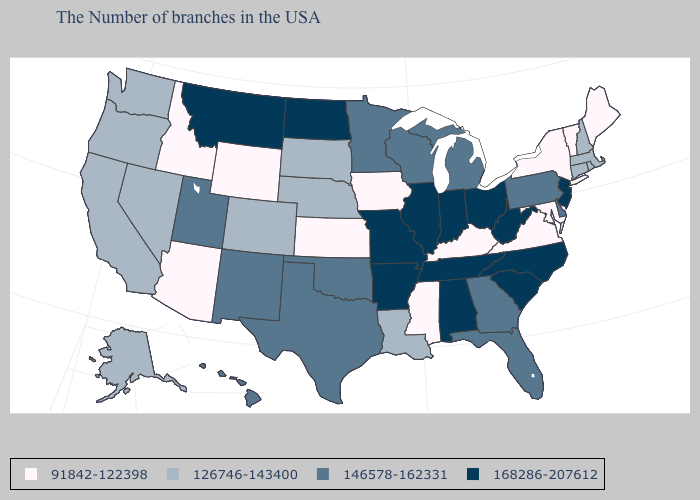Name the states that have a value in the range 91842-122398?
Keep it brief. Maine, Vermont, New York, Maryland, Virginia, Kentucky, Mississippi, Iowa, Kansas, Wyoming, Arizona, Idaho. What is the highest value in the USA?
Write a very short answer. 168286-207612. Among the states that border Ohio , which have the highest value?
Short answer required. West Virginia, Indiana. Name the states that have a value in the range 146578-162331?
Keep it brief. Delaware, Pennsylvania, Florida, Georgia, Michigan, Wisconsin, Minnesota, Oklahoma, Texas, New Mexico, Utah, Hawaii. Does the map have missing data?
Be succinct. No. What is the value of New Hampshire?
Quick response, please. 126746-143400. Among the states that border Tennessee , which have the highest value?
Write a very short answer. North Carolina, Alabama, Missouri, Arkansas. Name the states that have a value in the range 91842-122398?
Give a very brief answer. Maine, Vermont, New York, Maryland, Virginia, Kentucky, Mississippi, Iowa, Kansas, Wyoming, Arizona, Idaho. Name the states that have a value in the range 91842-122398?
Quick response, please. Maine, Vermont, New York, Maryland, Virginia, Kentucky, Mississippi, Iowa, Kansas, Wyoming, Arizona, Idaho. Name the states that have a value in the range 146578-162331?
Answer briefly. Delaware, Pennsylvania, Florida, Georgia, Michigan, Wisconsin, Minnesota, Oklahoma, Texas, New Mexico, Utah, Hawaii. Name the states that have a value in the range 146578-162331?
Short answer required. Delaware, Pennsylvania, Florida, Georgia, Michigan, Wisconsin, Minnesota, Oklahoma, Texas, New Mexico, Utah, Hawaii. Name the states that have a value in the range 126746-143400?
Concise answer only. Massachusetts, Rhode Island, New Hampshire, Connecticut, Louisiana, Nebraska, South Dakota, Colorado, Nevada, California, Washington, Oregon, Alaska. Name the states that have a value in the range 146578-162331?
Write a very short answer. Delaware, Pennsylvania, Florida, Georgia, Michigan, Wisconsin, Minnesota, Oklahoma, Texas, New Mexico, Utah, Hawaii. Does Idaho have the lowest value in the West?
Keep it brief. Yes. 